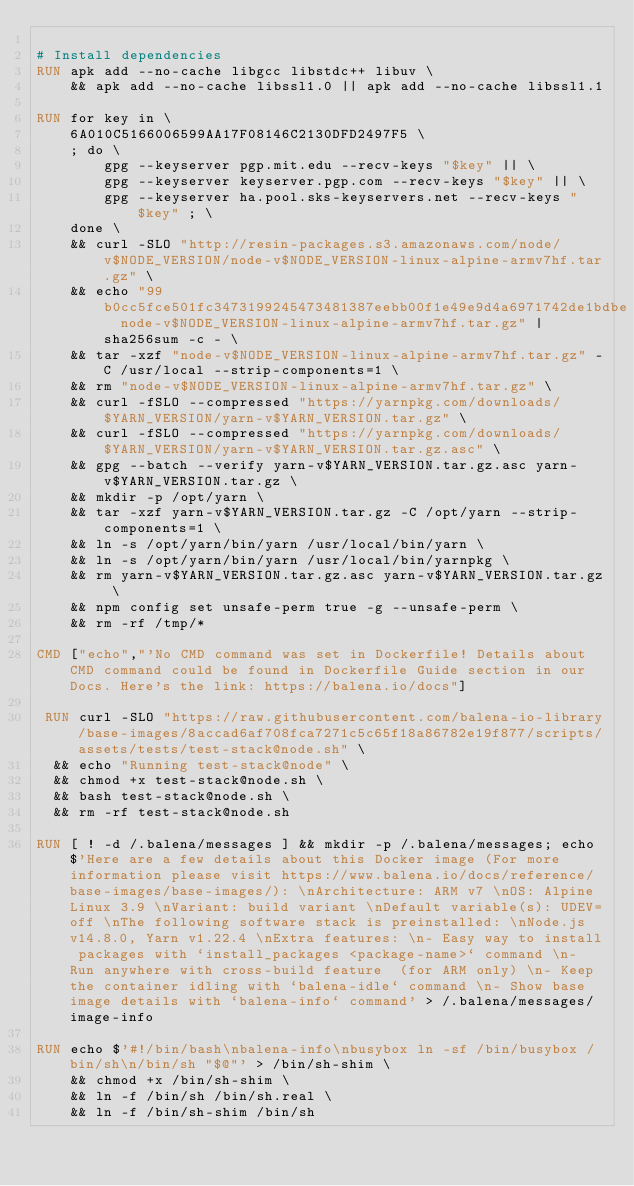Convert code to text. <code><loc_0><loc_0><loc_500><loc_500><_Dockerfile_>
# Install dependencies
RUN apk add --no-cache libgcc libstdc++ libuv \
	&& apk add --no-cache libssl1.0 || apk add --no-cache libssl1.1

RUN for key in \
	6A010C5166006599AA17F08146C2130DFD2497F5 \
	; do \
		gpg --keyserver pgp.mit.edu --recv-keys "$key" || \
		gpg --keyserver keyserver.pgp.com --recv-keys "$key" || \
		gpg --keyserver ha.pool.sks-keyservers.net --recv-keys "$key" ; \
	done \
	&& curl -SLO "http://resin-packages.s3.amazonaws.com/node/v$NODE_VERSION/node-v$NODE_VERSION-linux-alpine-armv7hf.tar.gz" \
	&& echo "99b0cc5fce501fc3473199245473481387eebb00f1e49e9d4a6971742de1bdbe  node-v$NODE_VERSION-linux-alpine-armv7hf.tar.gz" | sha256sum -c - \
	&& tar -xzf "node-v$NODE_VERSION-linux-alpine-armv7hf.tar.gz" -C /usr/local --strip-components=1 \
	&& rm "node-v$NODE_VERSION-linux-alpine-armv7hf.tar.gz" \
	&& curl -fSLO --compressed "https://yarnpkg.com/downloads/$YARN_VERSION/yarn-v$YARN_VERSION.tar.gz" \
	&& curl -fSLO --compressed "https://yarnpkg.com/downloads/$YARN_VERSION/yarn-v$YARN_VERSION.tar.gz.asc" \
	&& gpg --batch --verify yarn-v$YARN_VERSION.tar.gz.asc yarn-v$YARN_VERSION.tar.gz \
	&& mkdir -p /opt/yarn \
	&& tar -xzf yarn-v$YARN_VERSION.tar.gz -C /opt/yarn --strip-components=1 \
	&& ln -s /opt/yarn/bin/yarn /usr/local/bin/yarn \
	&& ln -s /opt/yarn/bin/yarn /usr/local/bin/yarnpkg \
	&& rm yarn-v$YARN_VERSION.tar.gz.asc yarn-v$YARN_VERSION.tar.gz \
	&& npm config set unsafe-perm true -g --unsafe-perm \
	&& rm -rf /tmp/*

CMD ["echo","'No CMD command was set in Dockerfile! Details about CMD command could be found in Dockerfile Guide section in our Docs. Here's the link: https://balena.io/docs"]

 RUN curl -SLO "https://raw.githubusercontent.com/balena-io-library/base-images/8accad6af708fca7271c5c65f18a86782e19f877/scripts/assets/tests/test-stack@node.sh" \
  && echo "Running test-stack@node" \
  && chmod +x test-stack@node.sh \
  && bash test-stack@node.sh \
  && rm -rf test-stack@node.sh 

RUN [ ! -d /.balena/messages ] && mkdir -p /.balena/messages; echo $'Here are a few details about this Docker image (For more information please visit https://www.balena.io/docs/reference/base-images/base-images/): \nArchitecture: ARM v7 \nOS: Alpine Linux 3.9 \nVariant: build variant \nDefault variable(s): UDEV=off \nThe following software stack is preinstalled: \nNode.js v14.8.0, Yarn v1.22.4 \nExtra features: \n- Easy way to install packages with `install_packages <package-name>` command \n- Run anywhere with cross-build feature  (for ARM only) \n- Keep the container idling with `balena-idle` command \n- Show base image details with `balena-info` command' > /.balena/messages/image-info

RUN echo $'#!/bin/bash\nbalena-info\nbusybox ln -sf /bin/busybox /bin/sh\n/bin/sh "$@"' > /bin/sh-shim \
	&& chmod +x /bin/sh-shim \
	&& ln -f /bin/sh /bin/sh.real \
	&& ln -f /bin/sh-shim /bin/sh</code> 